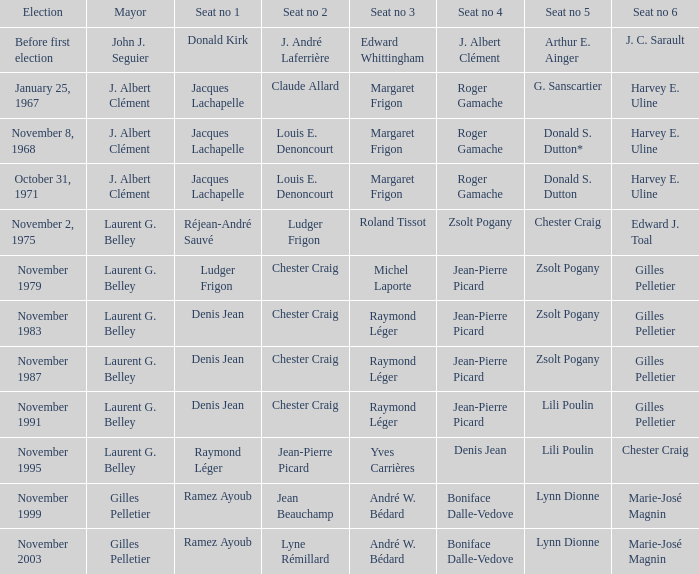In which election did jacques lachapelle occupy seat number 1 while g. sanscartier held seat number 5? January 25, 1967. 